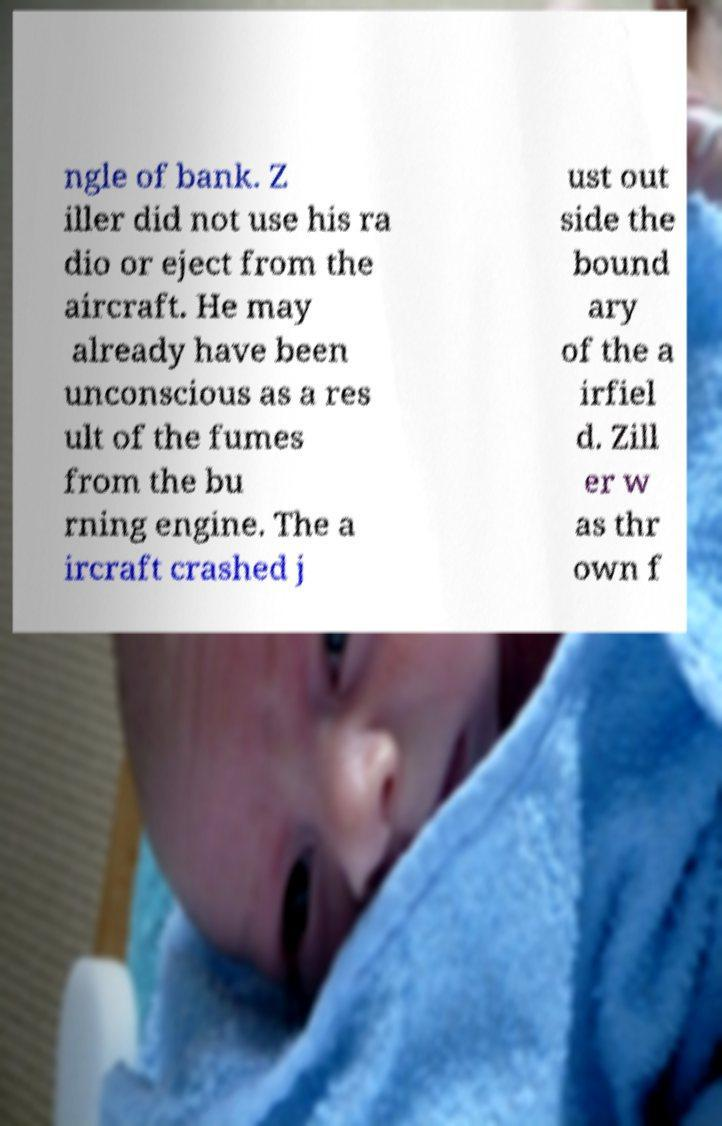Can you accurately transcribe the text from the provided image for me? ngle of bank. Z iller did not use his ra dio or eject from the aircraft. He may already have been unconscious as a res ult of the fumes from the bu rning engine. The a ircraft crashed j ust out side the bound ary of the a irfiel d. Zill er w as thr own f 